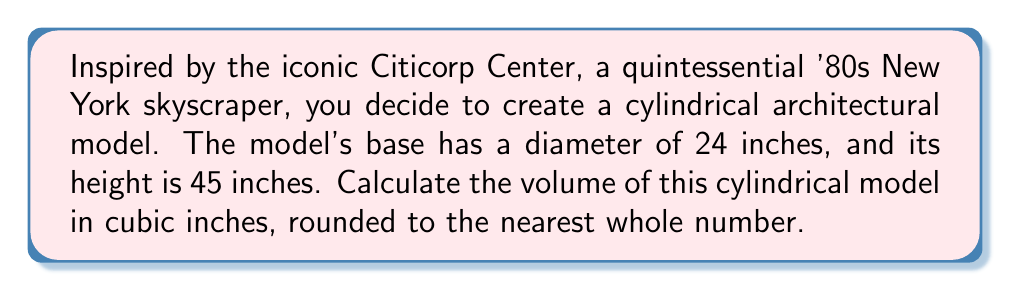Help me with this question. To find the volume of a cylinder, we use the formula:

$$V = \pi r^2 h$$

Where:
$V$ = volume
$r$ = radius of the base
$h$ = height of the cylinder

Let's break down the solution step-by-step:

1. Determine the radius:
   The diameter is 24 inches, so the radius is half of that.
   $r = 24 \div 2 = 12$ inches

2. We're given the height:
   $h = 45$ inches

3. Now, let's substitute these values into our formula:

   $$V = \pi (12\text{ in})^2 (45\text{ in})$$

4. Simplify the expression inside the parentheses:
   
   $$V = \pi (144\text{ in}^2) (45\text{ in})$$

5. Multiply the numbers:
   
   $$V = \pi (6,480\text{ in}^3)$$

6. Multiply by $\pi$ and round to the nearest whole number:
   
   $$V \approx 20,358\text{ in}^3$$

Thus, the volume of the cylindrical model is approximately 20,358 cubic inches.

[asy]
import geometry;

size(200);
real r = 3;
real h = 5.625;

path base = circle((0,0), r);
path top = circle((0,h), r);

draw(base);
draw(top);
draw((r,0)--(r,h));
draw((-r,0)--(-r,h));

label("24\"", (r,h/2), E);
label("45\"", (0,h/2), W);

draw((0,0)--(0,h), dashed);
draw((0,0)--(r,0), dashed);
label("12\"", (r/2,0), S);
[/asy]
Answer: $20,358\text{ in}^3$ 